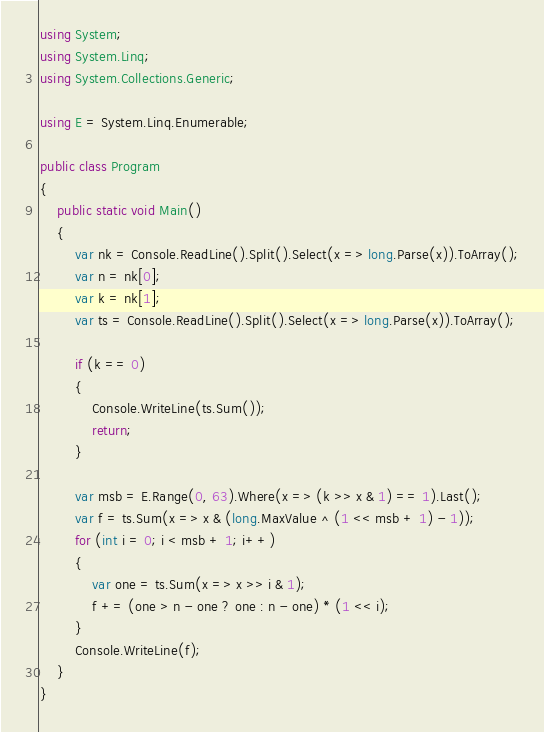<code> <loc_0><loc_0><loc_500><loc_500><_C#_>using System;
using System.Linq;
using System.Collections.Generic;

using E = System.Linq.Enumerable;

public class Program
{
    public static void Main()
    {
        var nk = Console.ReadLine().Split().Select(x => long.Parse(x)).ToArray();
        var n = nk[0];
        var k = nk[1];
        var ts = Console.ReadLine().Split().Select(x => long.Parse(x)).ToArray();

        if (k == 0)
        {
            Console.WriteLine(ts.Sum());
            return;
        }

        var msb = E.Range(0, 63).Where(x => (k >> x & 1) == 1).Last();
        var f = ts.Sum(x => x & (long.MaxValue ^ (1 << msb + 1) - 1));
        for (int i = 0; i < msb + 1; i++)
        {
            var one = ts.Sum(x => x >> i & 1);
            f += (one > n - one ? one : n - one) * (1 << i);
        }
        Console.WriteLine(f);
    }
}
</code> 